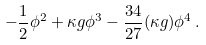<formula> <loc_0><loc_0><loc_500><loc_500>- \frac { 1 } { 2 } \phi ^ { 2 } + \kappa g \phi ^ { 3 } - \frac { 3 4 } { 2 7 } ( \kappa g ) \phi ^ { 4 } \, .</formula> 